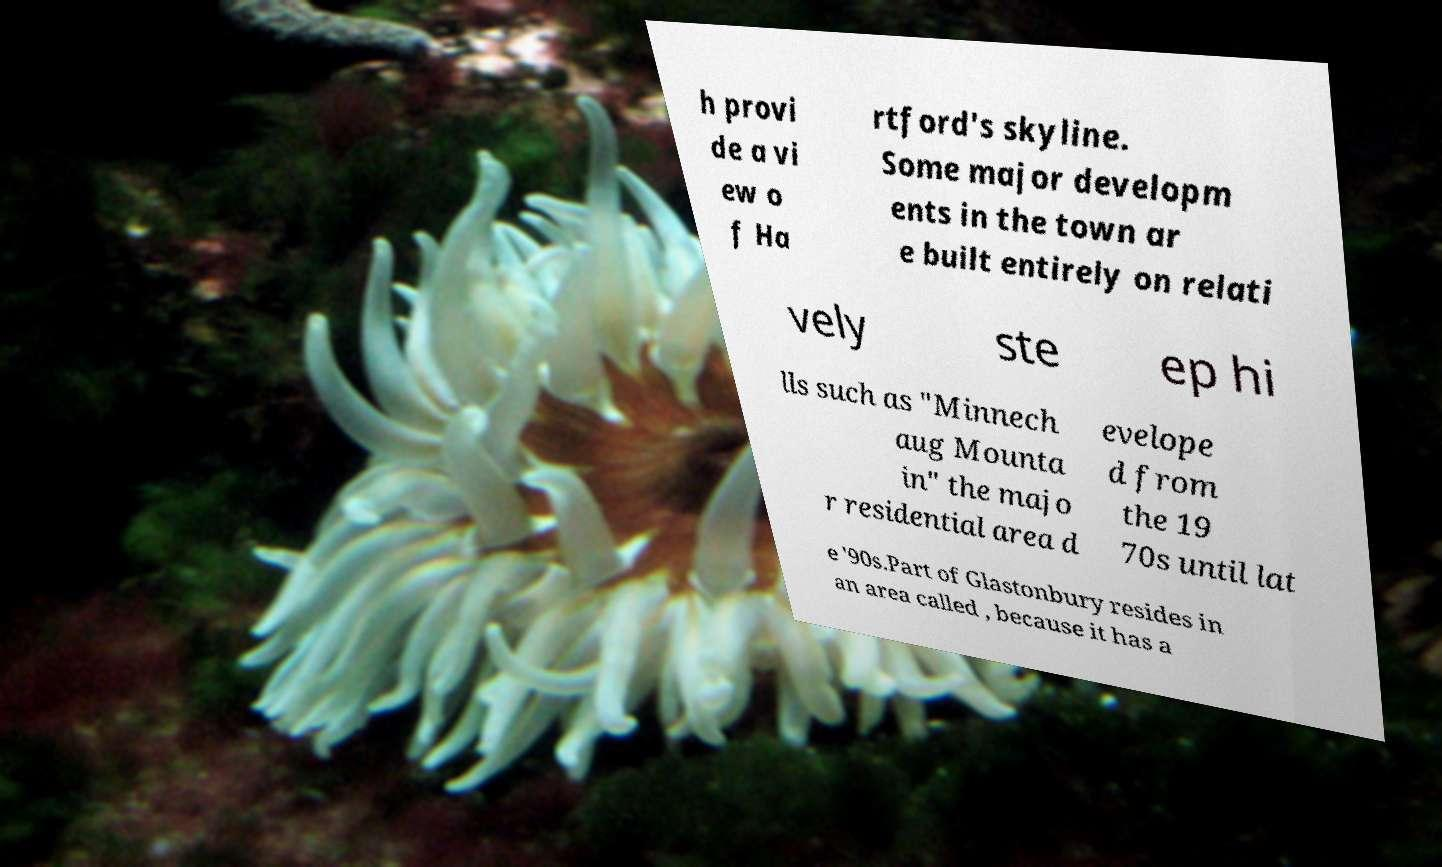Please identify and transcribe the text found in this image. h provi de a vi ew o f Ha rtford's skyline. Some major developm ents in the town ar e built entirely on relati vely ste ep hi lls such as "Minnech aug Mounta in" the majo r residential area d evelope d from the 19 70s until lat e '90s.Part of Glastonbury resides in an area called , because it has a 